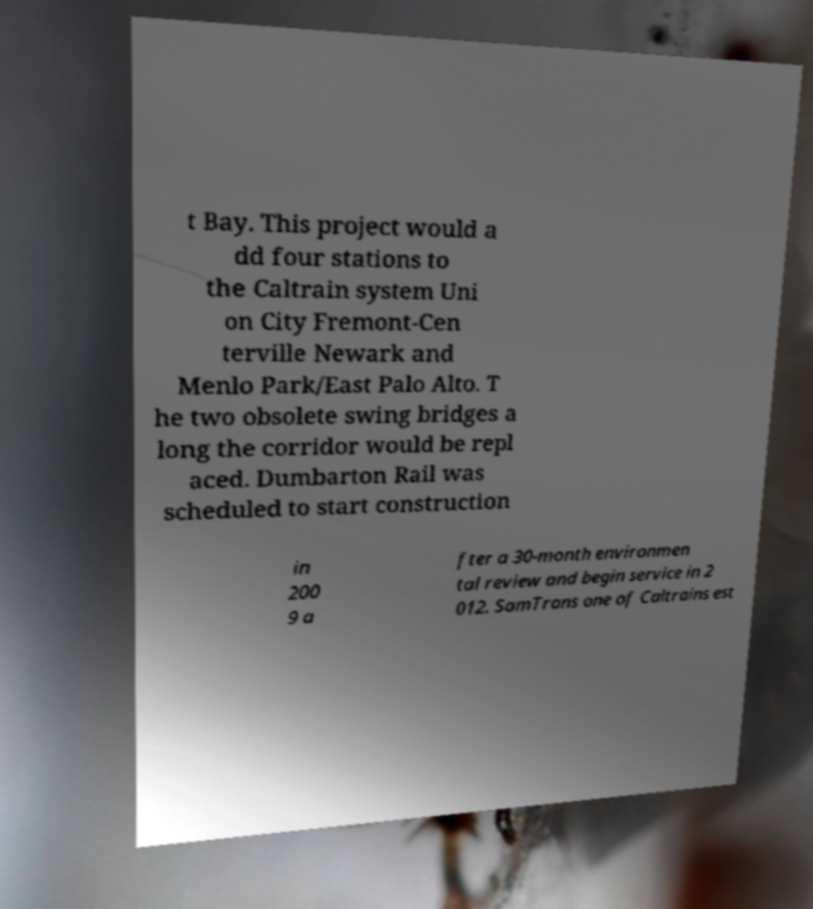Can you read and provide the text displayed in the image?This photo seems to have some interesting text. Can you extract and type it out for me? t Bay. This project would a dd four stations to the Caltrain system Uni on City Fremont-Cen terville Newark and Menlo Park/East Palo Alto. T he two obsolete swing bridges a long the corridor would be repl aced. Dumbarton Rail was scheduled to start construction in 200 9 a fter a 30-month environmen tal review and begin service in 2 012. SamTrans one of Caltrains est 